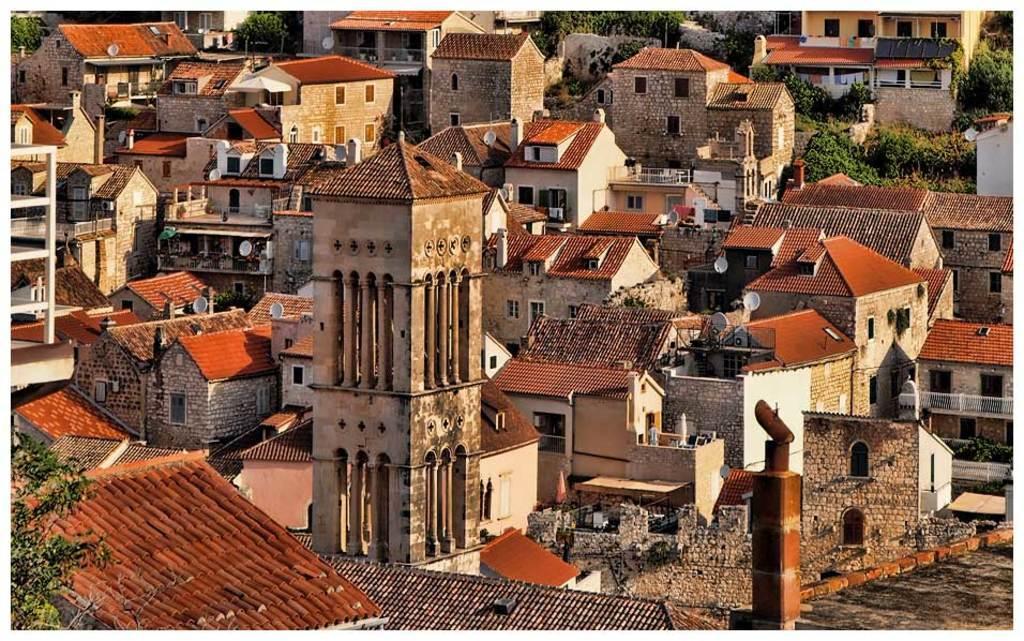How would you summarize this image in a sentence or two? In this picture I can see there are some buildings and there are doors and windows to the buildings and there are some trees. 